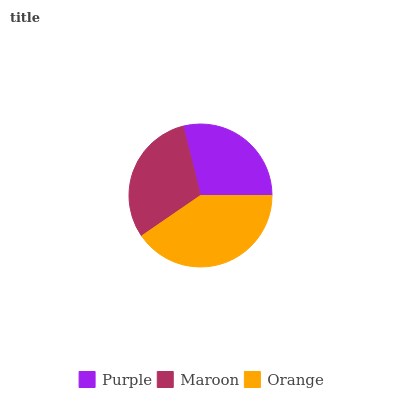Is Purple the minimum?
Answer yes or no. Yes. Is Orange the maximum?
Answer yes or no. Yes. Is Maroon the minimum?
Answer yes or no. No. Is Maroon the maximum?
Answer yes or no. No. Is Maroon greater than Purple?
Answer yes or no. Yes. Is Purple less than Maroon?
Answer yes or no. Yes. Is Purple greater than Maroon?
Answer yes or no. No. Is Maroon less than Purple?
Answer yes or no. No. Is Maroon the high median?
Answer yes or no. Yes. Is Maroon the low median?
Answer yes or no. Yes. Is Purple the high median?
Answer yes or no. No. Is Orange the low median?
Answer yes or no. No. 